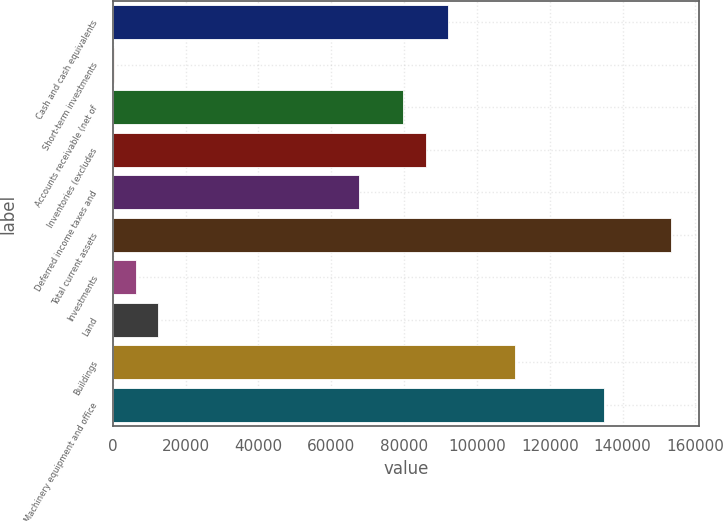Convert chart to OTSL. <chart><loc_0><loc_0><loc_500><loc_500><bar_chart><fcel>Cash and cash equivalents<fcel>Short-term investments<fcel>Accounts receivable (net of<fcel>Inventories (excludes<fcel>Deferred income taxes and<fcel>Total current assets<fcel>Investments<fcel>Land<fcel>Buildings<fcel>Machinery equipment and office<nl><fcel>92081<fcel>293<fcel>79842.6<fcel>85961.8<fcel>67604.2<fcel>153273<fcel>6412.2<fcel>12531.4<fcel>110439<fcel>134915<nl></chart> 